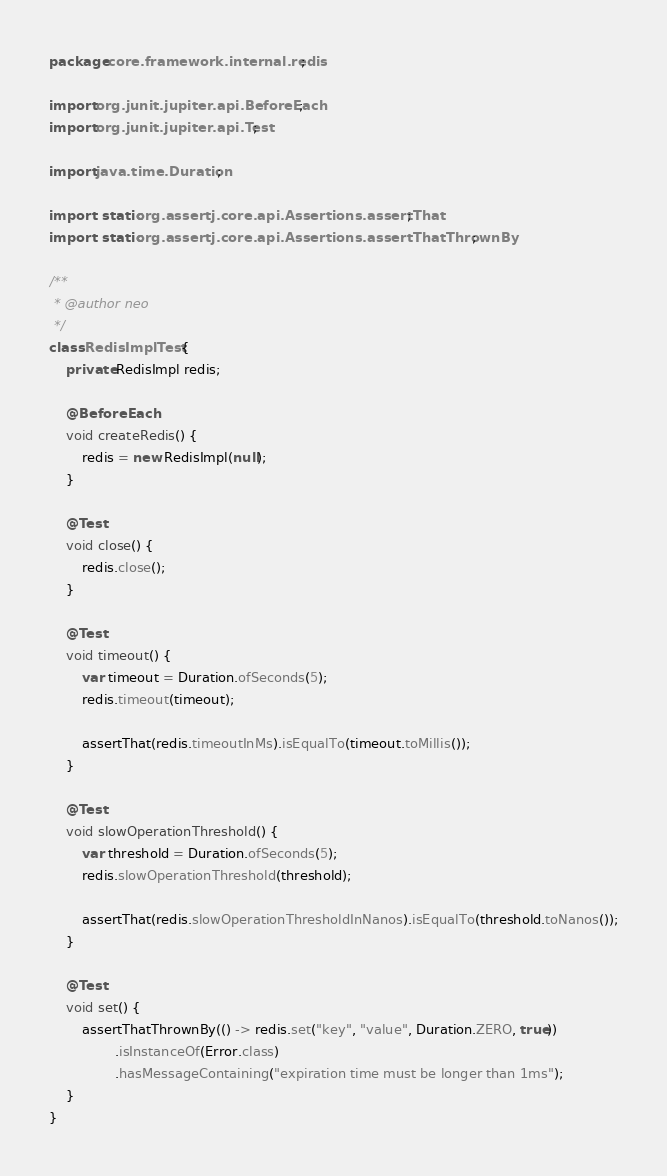<code> <loc_0><loc_0><loc_500><loc_500><_Java_>package core.framework.internal.redis;

import org.junit.jupiter.api.BeforeEach;
import org.junit.jupiter.api.Test;

import java.time.Duration;

import static org.assertj.core.api.Assertions.assertThat;
import static org.assertj.core.api.Assertions.assertThatThrownBy;

/**
 * @author neo
 */
class RedisImplTest {
    private RedisImpl redis;

    @BeforeEach
    void createRedis() {
        redis = new RedisImpl(null);
    }

    @Test
    void close() {
        redis.close();
    }

    @Test
    void timeout() {
        var timeout = Duration.ofSeconds(5);
        redis.timeout(timeout);

        assertThat(redis.timeoutInMs).isEqualTo(timeout.toMillis());
    }

    @Test
    void slowOperationThreshold() {
        var threshold = Duration.ofSeconds(5);
        redis.slowOperationThreshold(threshold);

        assertThat(redis.slowOperationThresholdInNanos).isEqualTo(threshold.toNanos());
    }

    @Test
    void set() {
        assertThatThrownBy(() -> redis.set("key", "value", Duration.ZERO, true))
                .isInstanceOf(Error.class)
                .hasMessageContaining("expiration time must be longer than 1ms");
    }
}
</code> 